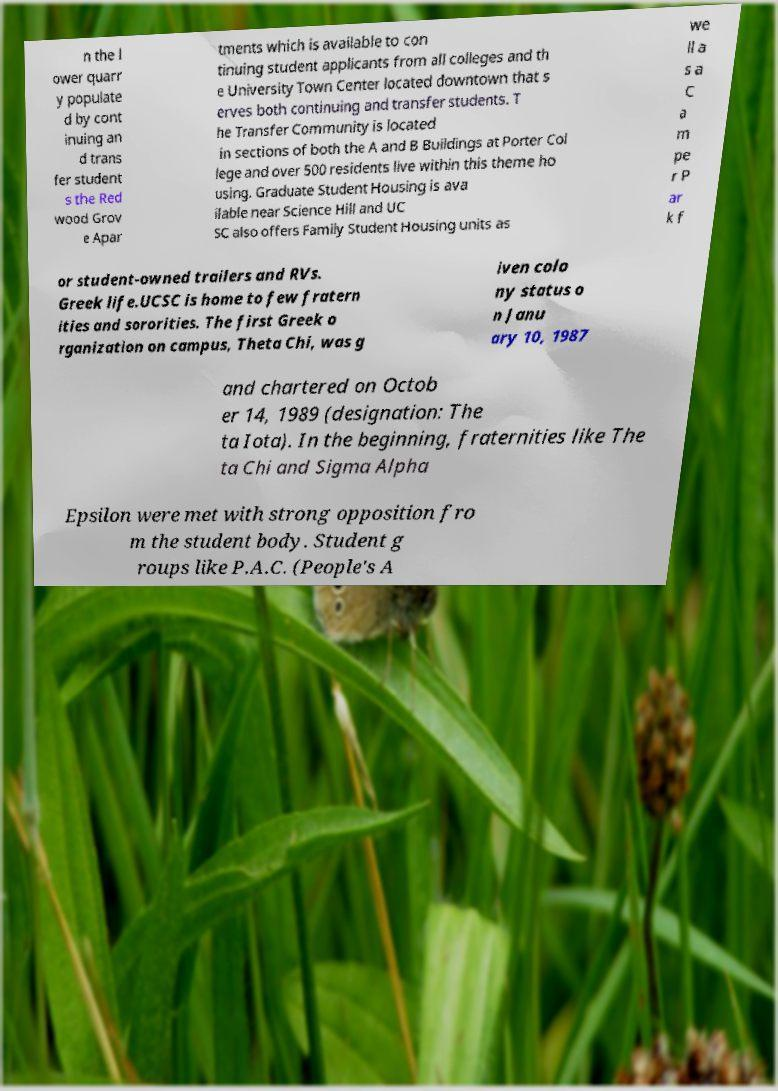Please identify and transcribe the text found in this image. n the l ower quarr y populate d by cont inuing an d trans fer student s the Red wood Grov e Apar tments which is available to con tinuing student applicants from all colleges and th e University Town Center located downtown that s erves both continuing and transfer students. T he Transfer Community is located in sections of both the A and B Buildings at Porter Col lege and over 500 residents live within this theme ho using. Graduate Student Housing is ava ilable near Science Hill and UC SC also offers Family Student Housing units as we ll a s a C a m pe r P ar k f or student-owned trailers and RVs. Greek life.UCSC is home to few fratern ities and sororities. The first Greek o rganization on campus, Theta Chi, was g iven colo ny status o n Janu ary 10, 1987 and chartered on Octob er 14, 1989 (designation: The ta Iota). In the beginning, fraternities like The ta Chi and Sigma Alpha Epsilon were met with strong opposition fro m the student body. Student g roups like P.A.C. (People's A 